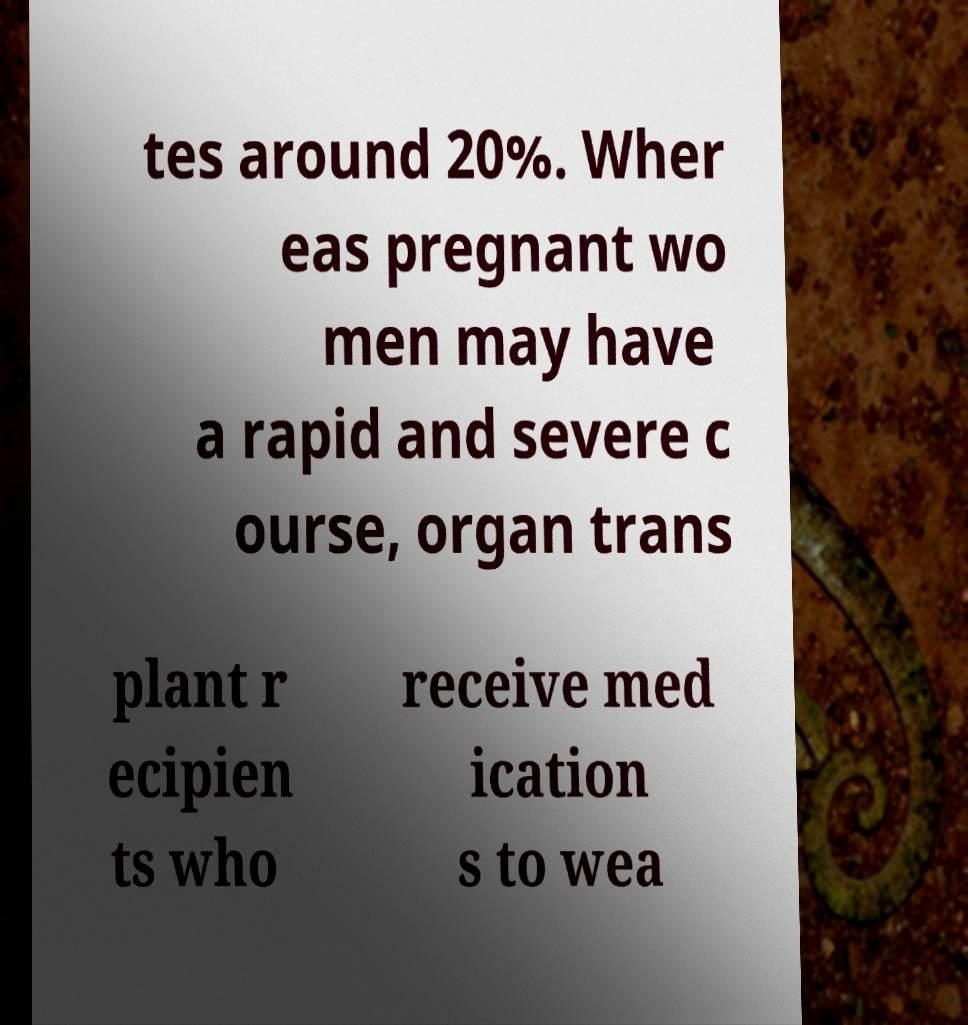What messages or text are displayed in this image? I need them in a readable, typed format. tes around 20%. Wher eas pregnant wo men may have a rapid and severe c ourse, organ trans plant r ecipien ts who receive med ication s to wea 